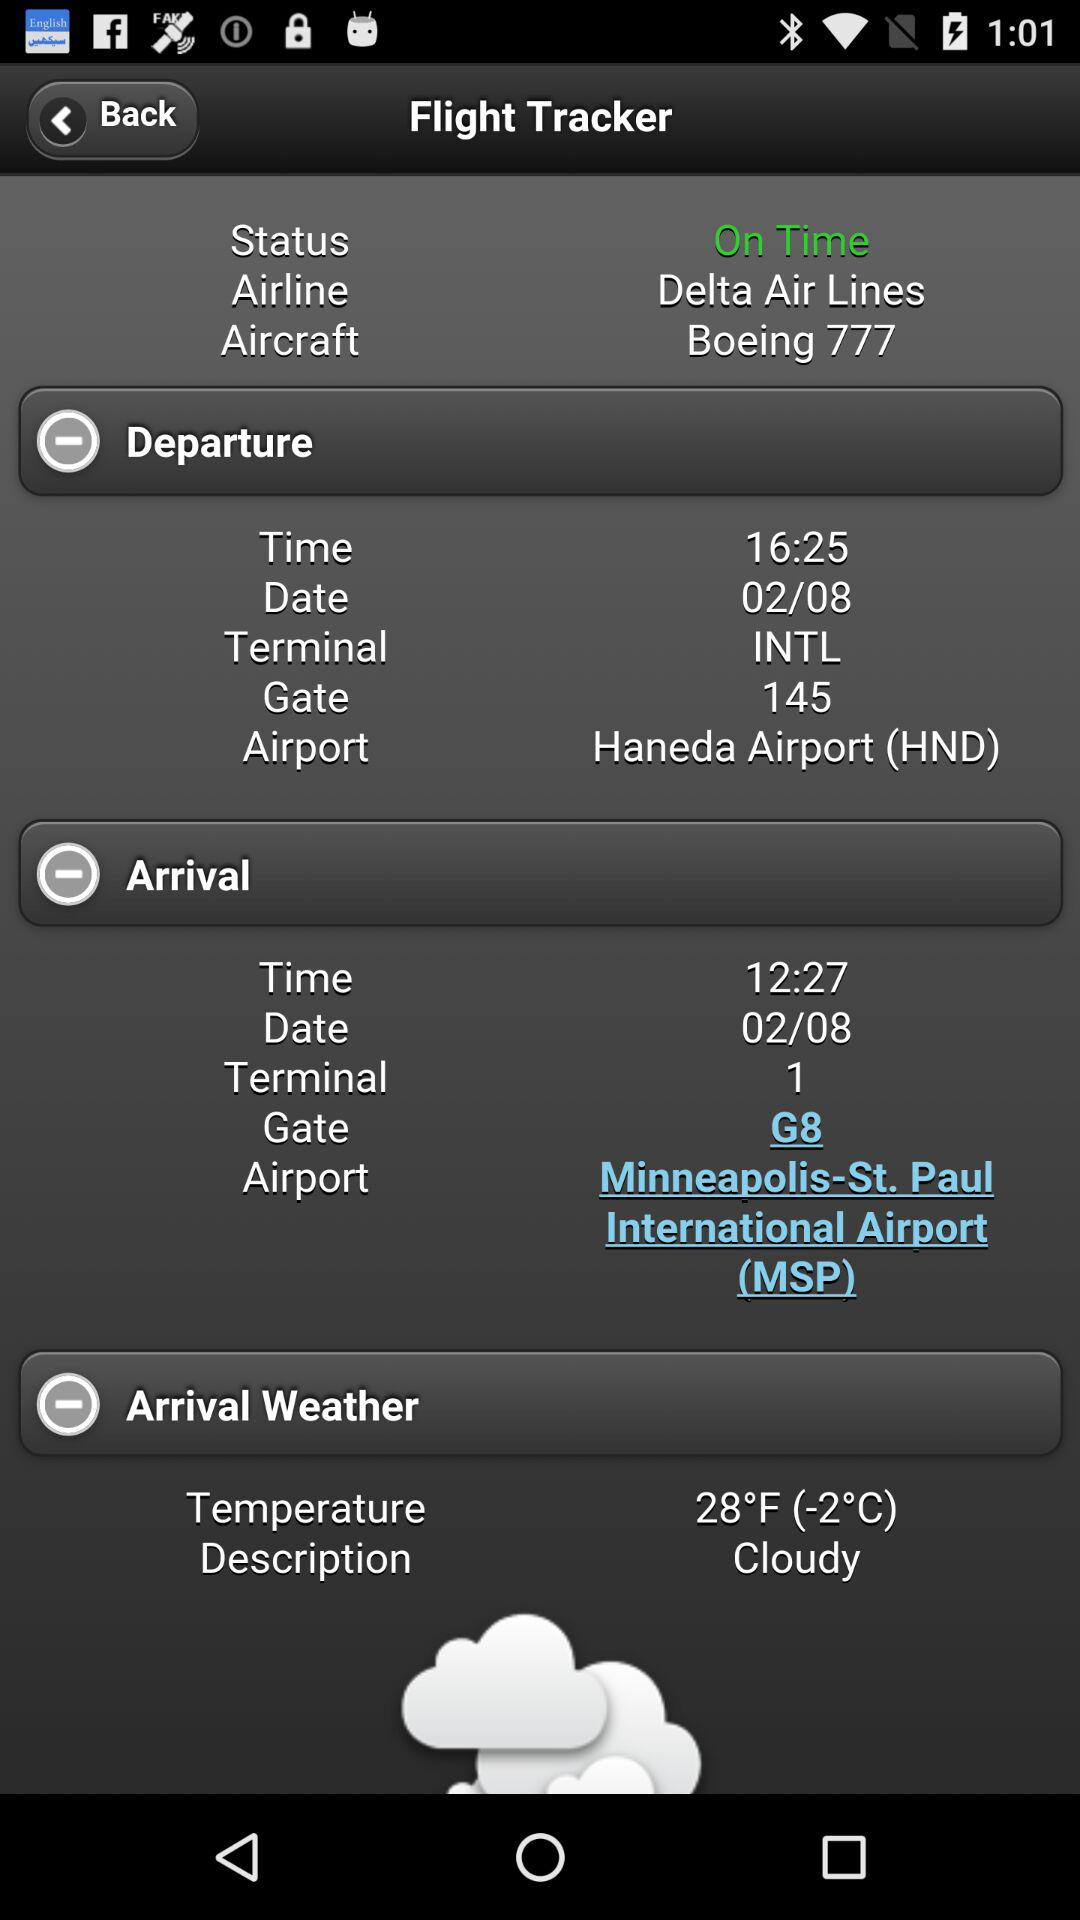What is the temperature at the arrival airport?
Answer the question using a single word or phrase. 28°F (-2°C) 